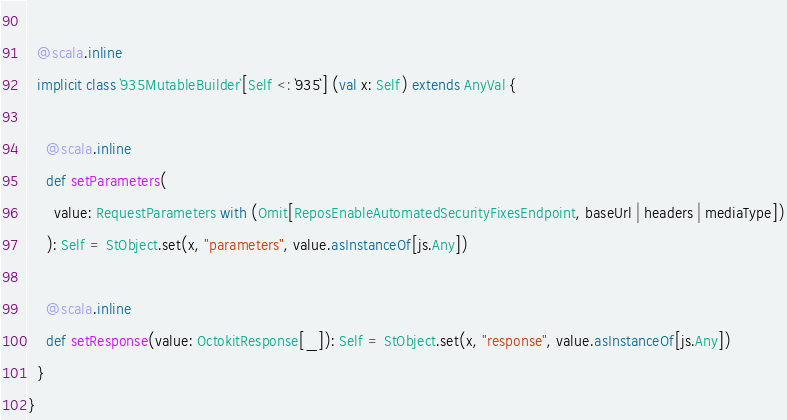<code> <loc_0><loc_0><loc_500><loc_500><_Scala_>  
  @scala.inline
  implicit class `935MutableBuilder`[Self <: `935`] (val x: Self) extends AnyVal {
    
    @scala.inline
    def setParameters(
      value: RequestParameters with (Omit[ReposEnableAutomatedSecurityFixesEndpoint, baseUrl | headers | mediaType])
    ): Self = StObject.set(x, "parameters", value.asInstanceOf[js.Any])
    
    @scala.inline
    def setResponse(value: OctokitResponse[_]): Self = StObject.set(x, "response", value.asInstanceOf[js.Any])
  }
}
</code> 